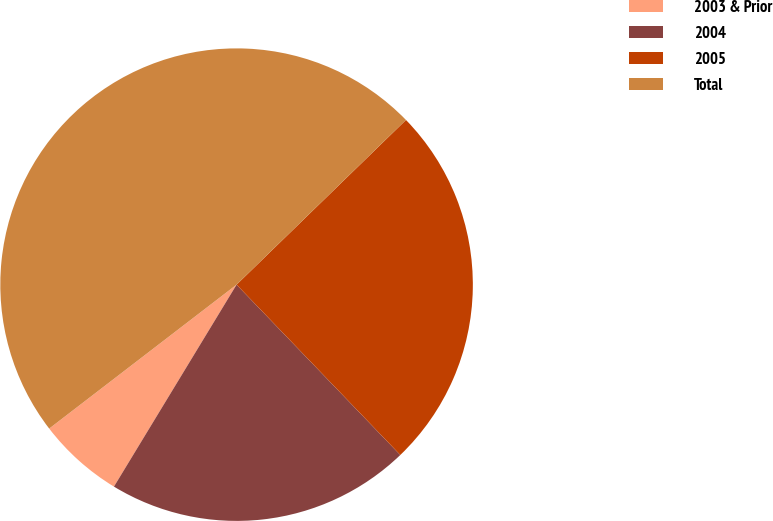<chart> <loc_0><loc_0><loc_500><loc_500><pie_chart><fcel>2003 & Prior<fcel>2004<fcel>2005<fcel>Total<nl><fcel>5.89%<fcel>20.87%<fcel>25.09%<fcel>48.15%<nl></chart> 